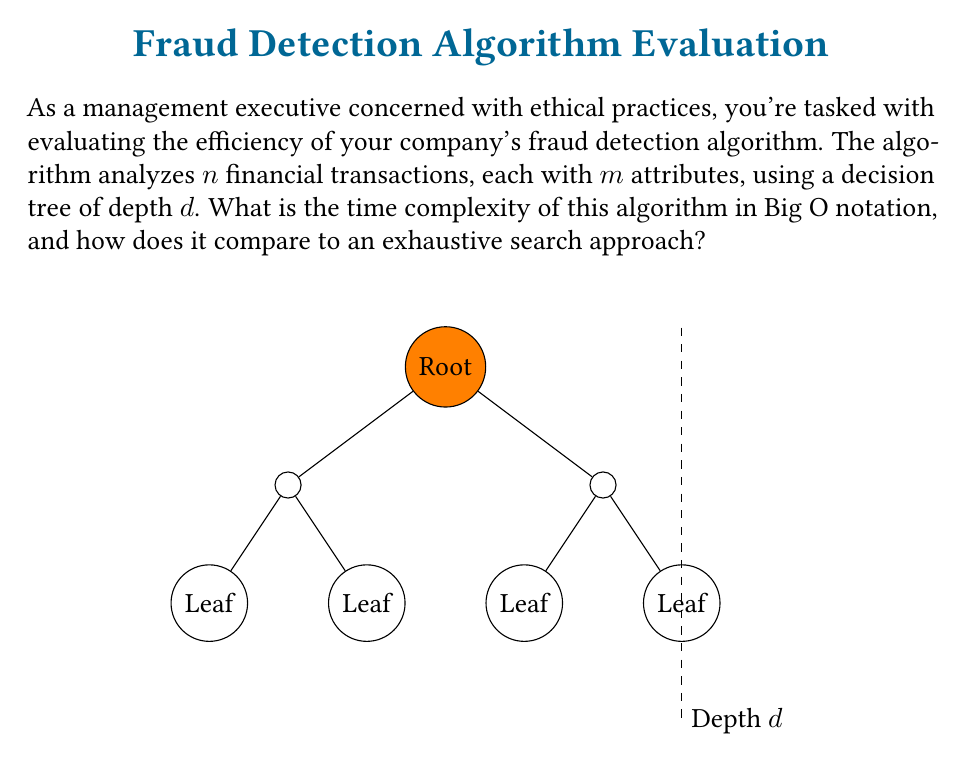Can you solve this math problem? Let's analyze this step-by-step:

1) In a decision tree algorithm, at each node, we make a decision based on one of the $m$ attributes of a transaction.

2) The depth $d$ of the tree represents the maximum number of decisions made for any single transaction.

3) For each transaction, we traverse the tree from root to leaf, making at most $d$ comparisons.

4) We need to do this for all $n$ transactions.

5) Therefore, the time complexity of the decision tree algorithm is $O(n \cdot d)$.

6) However, we also need to consider the complexity of comparing attributes at each node. Each comparison involves checking $m$ attributes.

7) Thus, the overall time complexity becomes $O(n \cdot d \cdot m)$.

8) In contrast, an exhaustive search approach would need to check all possible combinations of $m$ attributes for each of the $n$ transactions, resulting in a time complexity of $O(n \cdot 2^m)$.

9) The decision tree approach is generally more efficient, especially when $d$ is significantly smaller than $2^m$, which is often the case in practical fraud detection scenarios.

10) From an ethical standpoint, the decision tree approach not only offers better performance but also provides more interpretable results, allowing for transparency in the fraud detection process.
Answer: $O(n \cdot d \cdot m)$ 